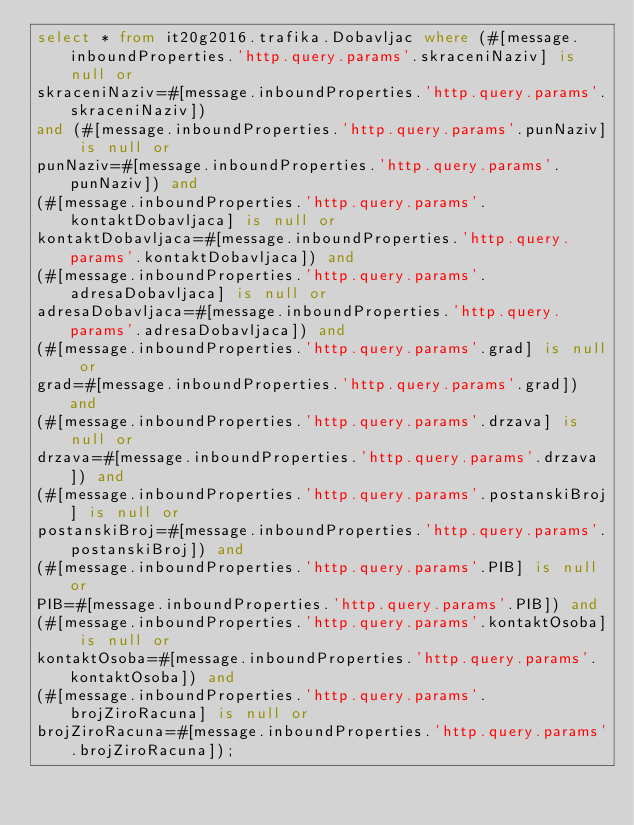Convert code to text. <code><loc_0><loc_0><loc_500><loc_500><_SQL_>select * from it20g2016.trafika.Dobavljac where (#[message.inboundProperties.'http.query.params'.skraceniNaziv] is null or 
skraceniNaziv=#[message.inboundProperties.'http.query.params'.skraceniNaziv])
and (#[message.inboundProperties.'http.query.params'.punNaziv] is null or 
punNaziv=#[message.inboundProperties.'http.query.params'.punNaziv]) and 
(#[message.inboundProperties.'http.query.params'.kontaktDobavljaca] is null or 
kontaktDobavljaca=#[message.inboundProperties.'http.query.params'.kontaktDobavljaca]) and 
(#[message.inboundProperties.'http.query.params'.adresaDobavljaca] is null or 
adresaDobavljaca=#[message.inboundProperties.'http.query.params'.adresaDobavljaca]) and 
(#[message.inboundProperties.'http.query.params'.grad] is null or 
grad=#[message.inboundProperties.'http.query.params'.grad]) and 
(#[message.inboundProperties.'http.query.params'.drzava] is null or 
drzava=#[message.inboundProperties.'http.query.params'.drzava]) and 
(#[message.inboundProperties.'http.query.params'.postanskiBroj] is null or 
postanskiBroj=#[message.inboundProperties.'http.query.params'.postanskiBroj]) and 
(#[message.inboundProperties.'http.query.params'.PIB] is null or 
PIB=#[message.inboundProperties.'http.query.params'.PIB]) and 
(#[message.inboundProperties.'http.query.params'.kontaktOsoba] is null or 
kontaktOsoba=#[message.inboundProperties.'http.query.params'.kontaktOsoba]) and 
(#[message.inboundProperties.'http.query.params'.brojZiroRacuna] is null or 
brojZiroRacuna=#[message.inboundProperties.'http.query.params'.brojZiroRacuna]);</code> 